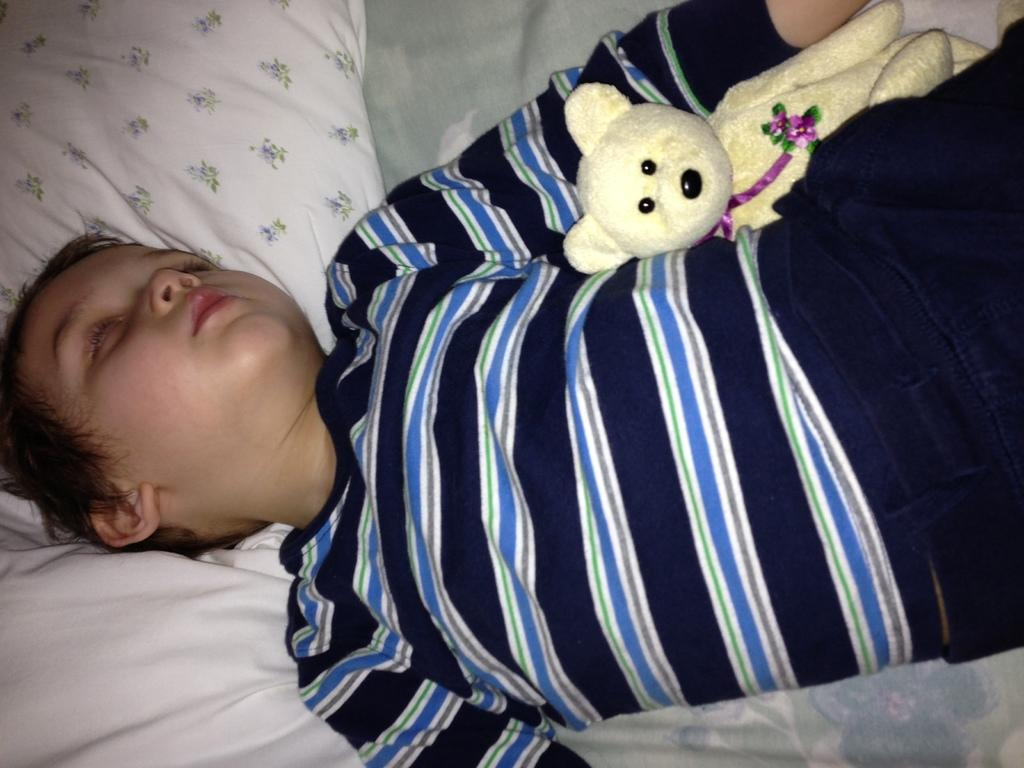Who is the main subject in the image? There is a boy in the image. What is the boy doing in the image? The boy is sleeping. What is the boy wearing in the image? The boy is wearing a black and blue color t-shirt. What object is beside the boy in the image? There is a teddy bear beside the boy. What is supporting the boy's head in the image? There is a white color pillow under the boy's head. How many feet can be seen in the image? There is no visible foot in the image; the boy is sleeping and covered by a blanket. 